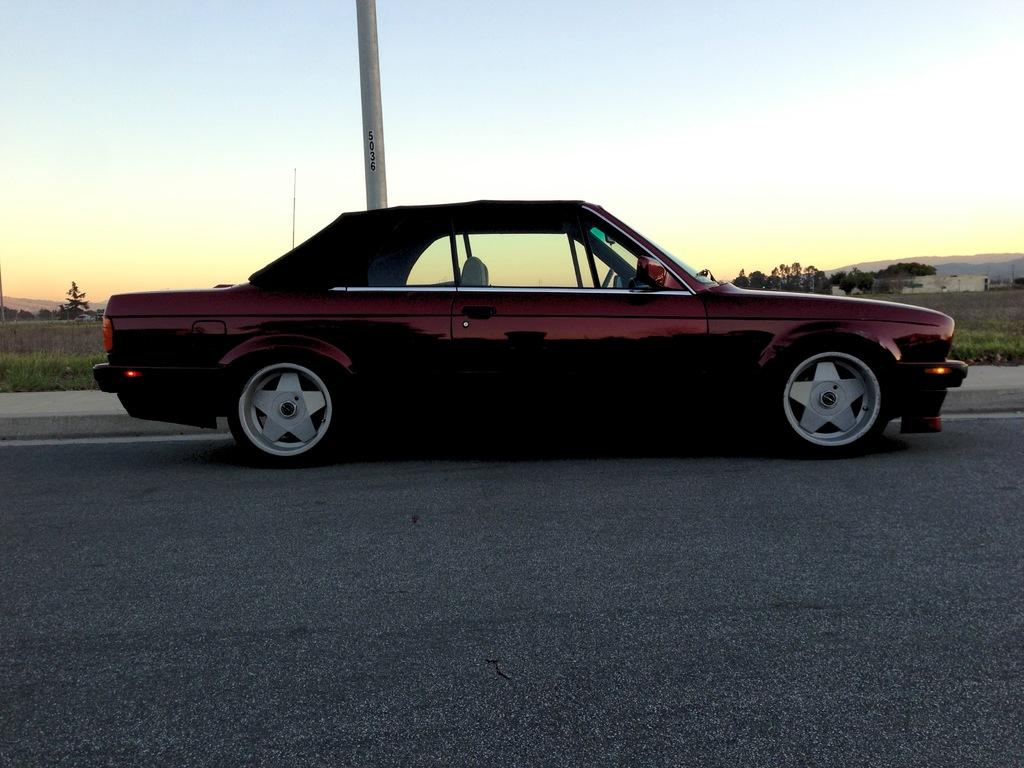What is the main subject of the image? There is a car on the road in the image. What can be seen in the background of the image? There is a pole, trees, grass, and the sky visible in the background of the image. What flavor of book can be seen on the car's dashboard in the image? There is no book present in the image, let alone a book with a flavor. 